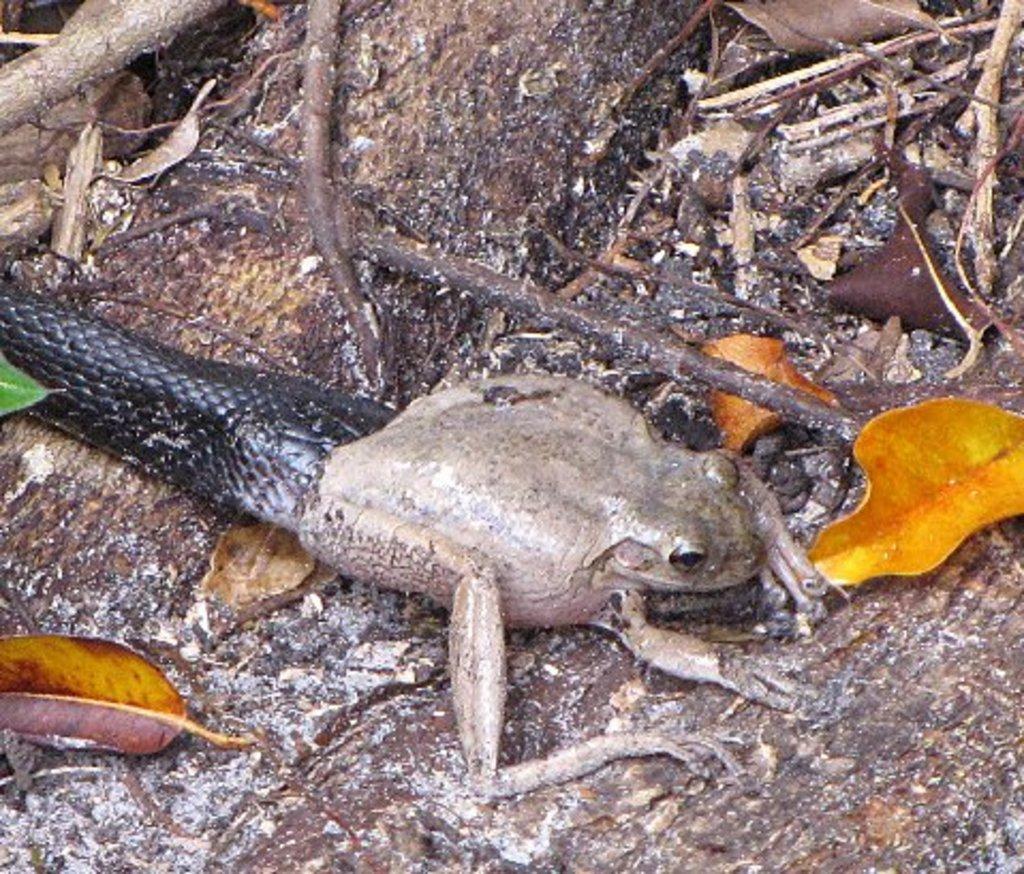Describe this image in one or two sentences. In this image we can see a frog, snake and dry leaves, twigs on the wooden surface. 